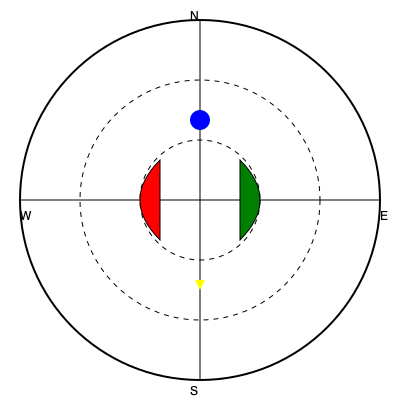Based on the simplified radar map, which direction is the storm system likely to move? To interpret the weather symbols on this simplified radar map, follow these steps:

1. Identify the symbols:
   - Green shape on the right: High-pressure system
   - Red shape on the left: Low-pressure system
   - Blue dot at the top: Area of precipitation
   - Yellow triangle at the bottom: Direction of wind

2. Understand the movement of weather systems:
   - In the Northern Hemisphere, wind circulates clockwise around high-pressure systems and counterclockwise around low-pressure systems.
   - Storm systems generally move from areas of high pressure to areas of low pressure.

3. Analyze the map:
   - The high-pressure system is on the right (east) side of the map.
   - The low-pressure system is on the left (west) side of the map.
   - The wind direction (yellow triangle) is pointing from north to south.

4. Conclude the likely movement:
   - Given the positions of the high and low-pressure systems, the storm is likely to move from east to west.
   - The wind direction supports this movement, as it would help push the system westward.

Therefore, based on the information provided in the radar map, the storm system is most likely to move westward.
Answer: West 